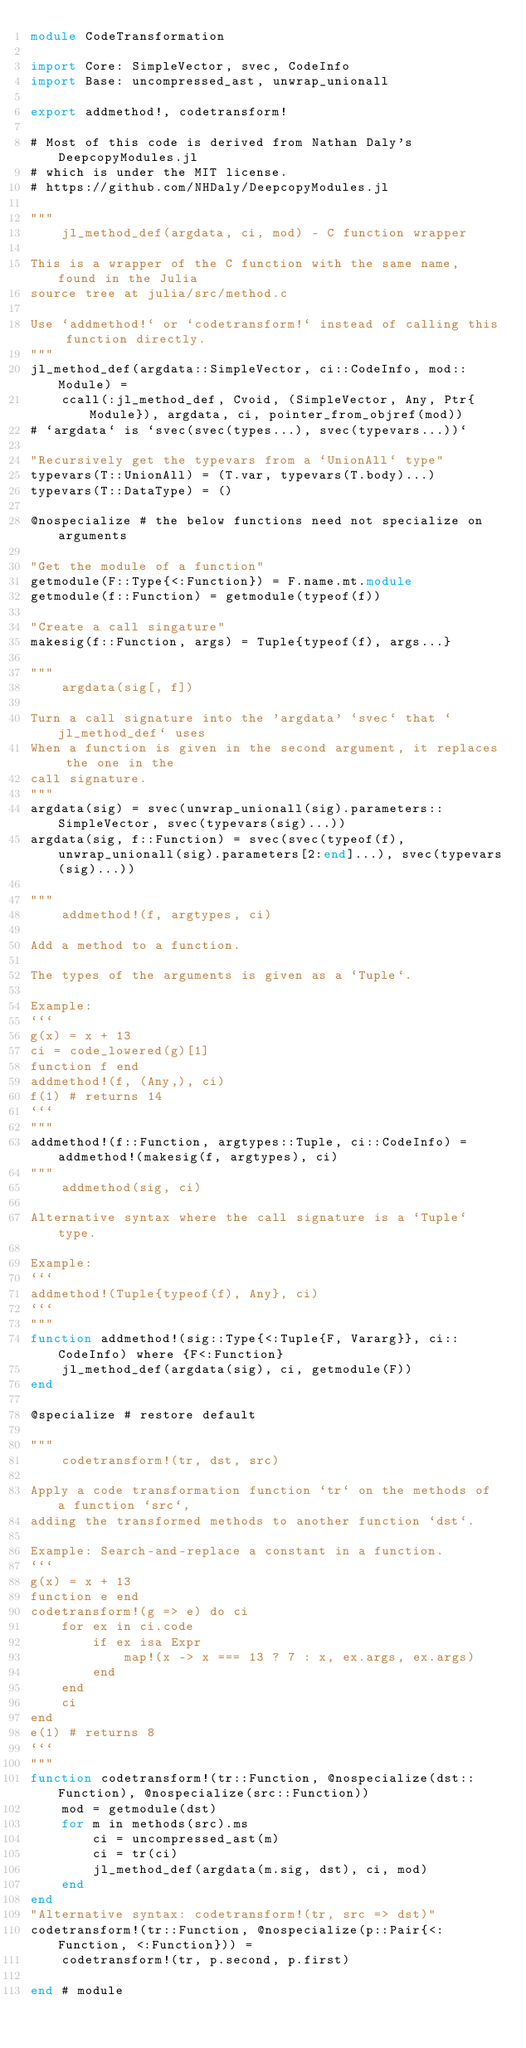Convert code to text. <code><loc_0><loc_0><loc_500><loc_500><_Julia_>module CodeTransformation

import Core: SimpleVector, svec, CodeInfo
import Base: uncompressed_ast, unwrap_unionall

export addmethod!, codetransform!

# Most of this code is derived from Nathan Daly's DeepcopyModules.jl
# which is under the MIT license.
# https://github.com/NHDaly/DeepcopyModules.jl

"""
    jl_method_def(argdata, ci, mod) - C function wrapper

This is a wrapper of the C function with the same name, found in the Julia
source tree at julia/src/method.c

Use `addmethod!` or `codetransform!` instead of calling this function directly.
"""
jl_method_def(argdata::SimpleVector, ci::CodeInfo, mod::Module) =
    ccall(:jl_method_def, Cvoid, (SimpleVector, Any, Ptr{Module}), argdata, ci, pointer_from_objref(mod))
# `argdata` is `svec(svec(types...), svec(typevars...))`

"Recursively get the typevars from a `UnionAll` type"
typevars(T::UnionAll) = (T.var, typevars(T.body)...)
typevars(T::DataType) = ()

@nospecialize # the below functions need not specialize on arguments

"Get the module of a function"
getmodule(F::Type{<:Function}) = F.name.mt.module
getmodule(f::Function) = getmodule(typeof(f))

"Create a call singature"
makesig(f::Function, args) = Tuple{typeof(f), args...}

"""
    argdata(sig[, f])

Turn a call signature into the 'argdata' `svec` that `jl_method_def` uses
When a function is given in the second argument, it replaces the one in the
call signature.
"""
argdata(sig) = svec(unwrap_unionall(sig).parameters::SimpleVector, svec(typevars(sig)...))
argdata(sig, f::Function) = svec(svec(typeof(f), unwrap_unionall(sig).parameters[2:end]...), svec(typevars(sig)...))

"""
    addmethod!(f, argtypes, ci)

Add a method to a function.

The types of the arguments is given as a `Tuple`.

Example:
```
g(x) = x + 13
ci = code_lowered(g)[1]
function f end
addmethod!(f, (Any,), ci)
f(1) # returns 14
```
"""
addmethod!(f::Function, argtypes::Tuple, ci::CodeInfo) = addmethod!(makesig(f, argtypes), ci)
"""
    addmethod(sig, ci)

Alternative syntax where the call signature is a `Tuple` type.

Example:
```
addmethod!(Tuple{typeof(f), Any}, ci)
```
"""
function addmethod!(sig::Type{<:Tuple{F, Vararg}}, ci::CodeInfo) where {F<:Function}
    jl_method_def(argdata(sig), ci, getmodule(F))
end

@specialize # restore default

"""
    codetransform!(tr, dst, src)

Apply a code transformation function `tr` on the methods of a function `src`,
adding the transformed methods to another function `dst`.

Example: Search-and-replace a constant in a function.
```
g(x) = x + 13
function e end
codetransform!(g => e) do ci
    for ex in ci.code
        if ex isa Expr
            map!(x -> x === 13 ? 7 : x, ex.args, ex.args)
        end
    end
    ci
end
e(1) # returns 8
```
"""
function codetransform!(tr::Function, @nospecialize(dst::Function), @nospecialize(src::Function))
    mod = getmodule(dst)
    for m in methods(src).ms
        ci = uncompressed_ast(m)
        ci = tr(ci)
        jl_method_def(argdata(m.sig, dst), ci, mod)
    end
end
"Alternative syntax: codetransform!(tr, src => dst)"
codetransform!(tr::Function, @nospecialize(p::Pair{<:Function, <:Function})) =
    codetransform!(tr, p.second, p.first)

end # module
</code> 